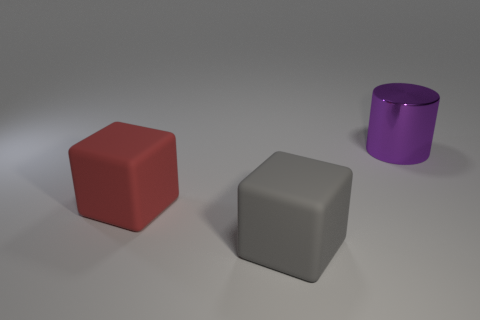Add 3 big red shiny blocks. How many objects exist? 6 Subtract all blocks. How many objects are left? 1 Add 2 big cubes. How many big cubes exist? 4 Subtract 0 brown cubes. How many objects are left? 3 Subtract all big things. Subtract all big yellow balls. How many objects are left? 0 Add 2 purple objects. How many purple objects are left? 3 